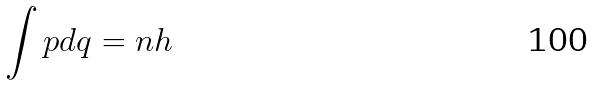Convert formula to latex. <formula><loc_0><loc_0><loc_500><loc_500>\int p d q = n h</formula> 